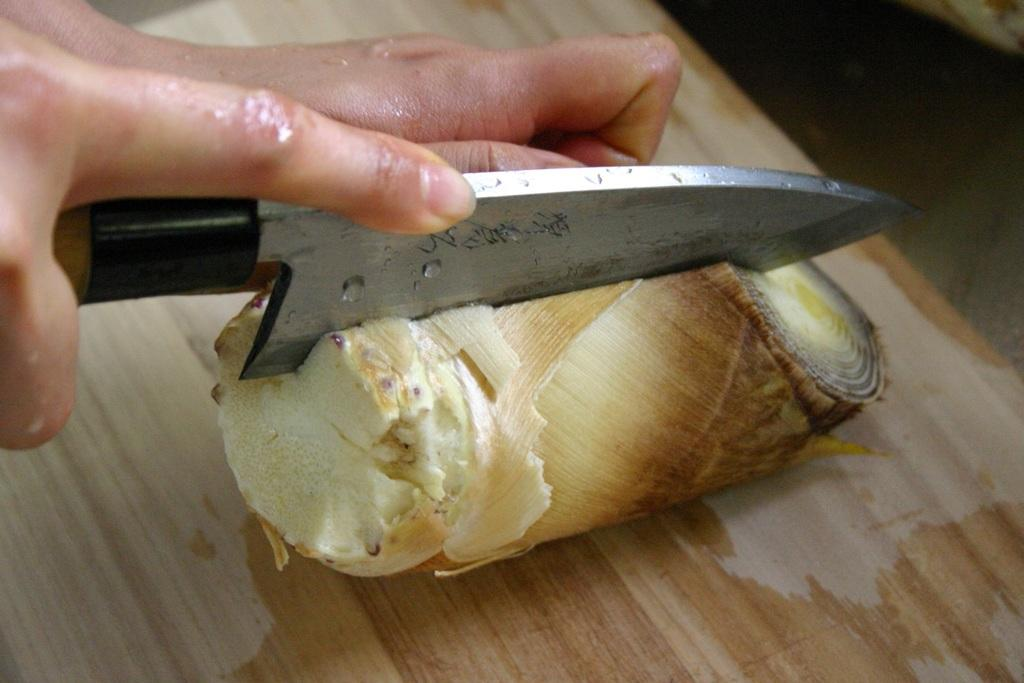What is being held by the human hands in the image? Human hands are holding a knife in the image. What is the purpose of the knife in the image? The knife is being used to cut an object. What is the object being cut resting on? The object is on a chopping board. What can be seen beneath the chopping board in the image? There is a surface visible in the image. Can you tell me the shape of the snake in the image? There is no snake present in the image. What book is the person reading in the image? There is no person reading a book in the image. 